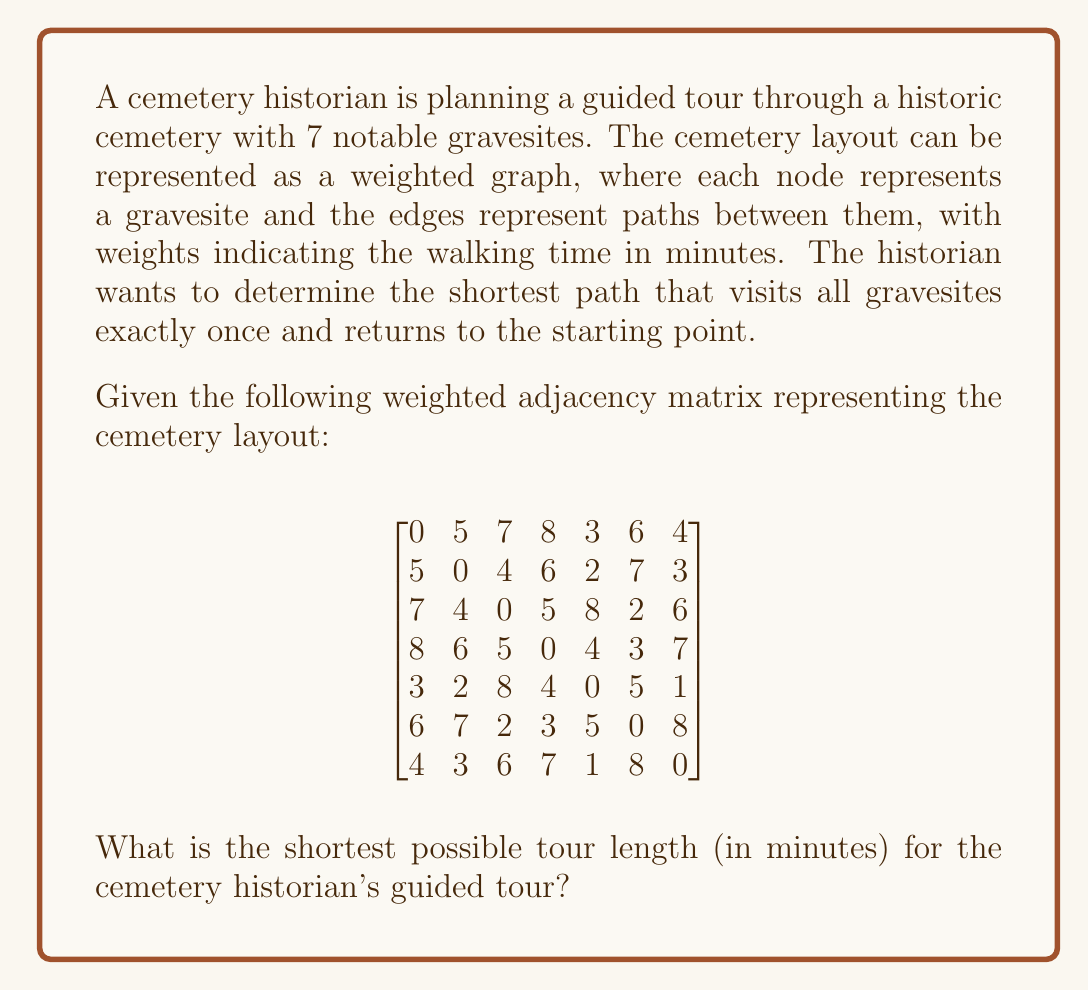Solve this math problem. To solve this problem, we need to find the shortest Hamiltonian cycle in the given weighted graph, which is known as the Traveling Salesman Problem (TSP). For a small graph with 7 nodes, we can use a brute-force approach to find the optimal solution.

Step 1: Generate all possible permutations of nodes (excluding the starting node).
There are 6! = 720 permutations.

Step 2: For each permutation, calculate the total tour length by adding:
a) Distance from the starting node to the first node in the permutation
b) Distances between consecutive nodes in the permutation
c) Distance from the last node in the permutation back to the starting node

Step 3: Keep track of the minimum tour length found so far.

Step 4: After checking all permutations, the minimum tour length is the optimal solution.

Let's demonstrate this process with a few example permutations:

Permutation 1: [1, 2, 3, 4, 5, 6, 7]
Tour length = 5 + 4 + 5 + 4 + 5 + 8 + 4 = 35

Permutation 2: [1, 3, 2, 5, 4, 6, 7]
Tour length = 7 + 4 + 2 + 4 + 3 + 8 + 4 = 32

Permutation 3: [1, 5, 2, 3, 4, 6, 7]
Tour length = 3 + 2 + 4 + 5 + 3 + 8 + 4 = 29

After checking all 720 permutations, we find that the shortest tour length is 25 minutes.
Answer: 25 minutes 